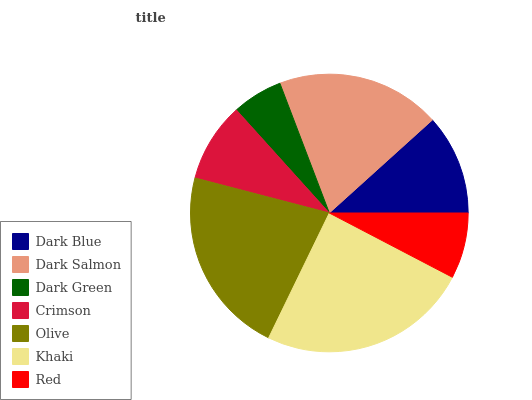Is Dark Green the minimum?
Answer yes or no. Yes. Is Khaki the maximum?
Answer yes or no. Yes. Is Dark Salmon the minimum?
Answer yes or no. No. Is Dark Salmon the maximum?
Answer yes or no. No. Is Dark Salmon greater than Dark Blue?
Answer yes or no. Yes. Is Dark Blue less than Dark Salmon?
Answer yes or no. Yes. Is Dark Blue greater than Dark Salmon?
Answer yes or no. No. Is Dark Salmon less than Dark Blue?
Answer yes or no. No. Is Dark Blue the high median?
Answer yes or no. Yes. Is Dark Blue the low median?
Answer yes or no. Yes. Is Olive the high median?
Answer yes or no. No. Is Khaki the low median?
Answer yes or no. No. 